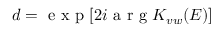<formula> <loc_0><loc_0><loc_500><loc_500>d = e x p [ 2 i a r g K _ { v w } ( E ) ]</formula> 